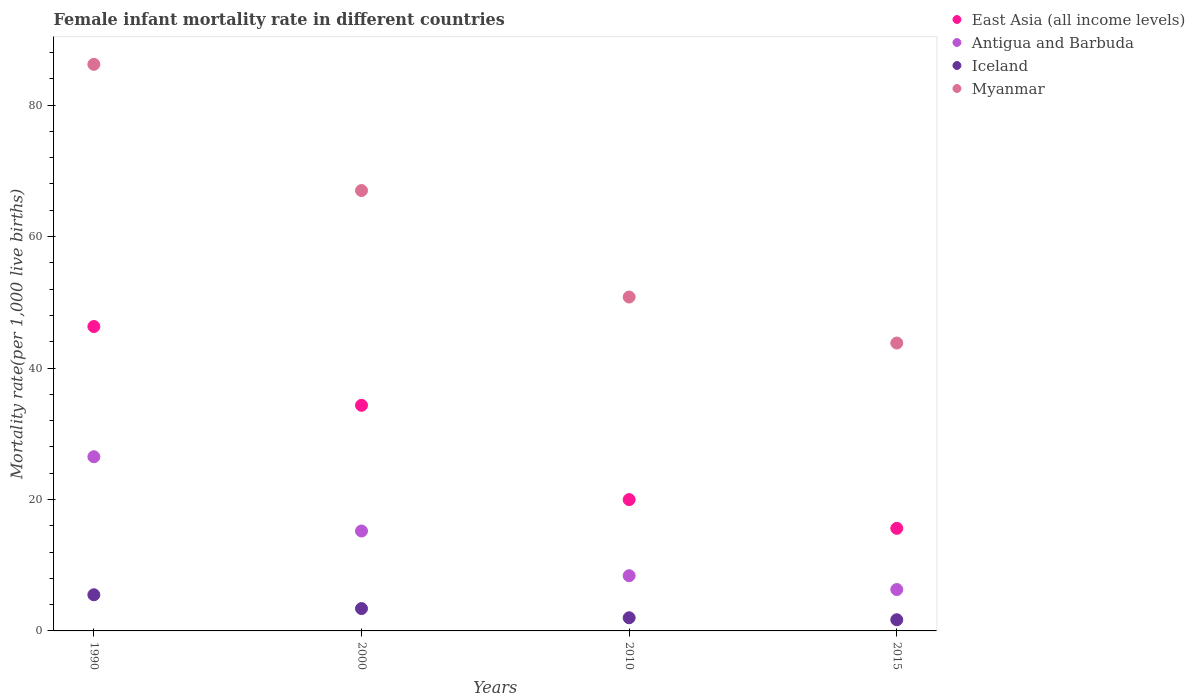How many different coloured dotlines are there?
Provide a succinct answer. 4. What is the female infant mortality rate in Myanmar in 2000?
Provide a short and direct response. 67. Across all years, what is the maximum female infant mortality rate in Iceland?
Provide a short and direct response. 5.5. In which year was the female infant mortality rate in East Asia (all income levels) maximum?
Keep it short and to the point. 1990. In which year was the female infant mortality rate in East Asia (all income levels) minimum?
Keep it short and to the point. 2015. What is the total female infant mortality rate in Antigua and Barbuda in the graph?
Your response must be concise. 56.4. What is the difference between the female infant mortality rate in Myanmar in 2015 and the female infant mortality rate in East Asia (all income levels) in 2010?
Your response must be concise. 23.82. What is the average female infant mortality rate in East Asia (all income levels) per year?
Ensure brevity in your answer.  29.06. In how many years, is the female infant mortality rate in Antigua and Barbuda greater than 52?
Offer a terse response. 0. Is the difference between the female infant mortality rate in Antigua and Barbuda in 2000 and 2015 greater than the difference between the female infant mortality rate in Iceland in 2000 and 2015?
Offer a very short reply. Yes. What is the difference between the highest and the second highest female infant mortality rate in Iceland?
Provide a short and direct response. 2.1. What is the difference between the highest and the lowest female infant mortality rate in Myanmar?
Make the answer very short. 42.4. Is the sum of the female infant mortality rate in Antigua and Barbuda in 2010 and 2015 greater than the maximum female infant mortality rate in Myanmar across all years?
Ensure brevity in your answer.  No. Is it the case that in every year, the sum of the female infant mortality rate in Myanmar and female infant mortality rate in East Asia (all income levels)  is greater than the sum of female infant mortality rate in Antigua and Barbuda and female infant mortality rate in Iceland?
Your response must be concise. Yes. Is it the case that in every year, the sum of the female infant mortality rate in Myanmar and female infant mortality rate in East Asia (all income levels)  is greater than the female infant mortality rate in Iceland?
Keep it short and to the point. Yes. Does the female infant mortality rate in Antigua and Barbuda monotonically increase over the years?
Ensure brevity in your answer.  No. Is the female infant mortality rate in Iceland strictly greater than the female infant mortality rate in Myanmar over the years?
Offer a very short reply. No. What is the difference between two consecutive major ticks on the Y-axis?
Offer a very short reply. 20. Are the values on the major ticks of Y-axis written in scientific E-notation?
Give a very brief answer. No. Where does the legend appear in the graph?
Keep it short and to the point. Top right. How many legend labels are there?
Provide a short and direct response. 4. What is the title of the graph?
Your answer should be compact. Female infant mortality rate in different countries. What is the label or title of the X-axis?
Offer a very short reply. Years. What is the label or title of the Y-axis?
Your answer should be compact. Mortality rate(per 1,0 live births). What is the Mortality rate(per 1,000 live births) in East Asia (all income levels) in 1990?
Ensure brevity in your answer.  46.31. What is the Mortality rate(per 1,000 live births) in Myanmar in 1990?
Your answer should be compact. 86.2. What is the Mortality rate(per 1,000 live births) in East Asia (all income levels) in 2000?
Make the answer very short. 34.33. What is the Mortality rate(per 1,000 live births) in East Asia (all income levels) in 2010?
Keep it short and to the point. 19.98. What is the Mortality rate(per 1,000 live births) in Iceland in 2010?
Give a very brief answer. 2. What is the Mortality rate(per 1,000 live births) in Myanmar in 2010?
Offer a very short reply. 50.8. What is the Mortality rate(per 1,000 live births) in East Asia (all income levels) in 2015?
Keep it short and to the point. 15.6. What is the Mortality rate(per 1,000 live births) in Antigua and Barbuda in 2015?
Your response must be concise. 6.3. What is the Mortality rate(per 1,000 live births) of Iceland in 2015?
Ensure brevity in your answer.  1.7. What is the Mortality rate(per 1,000 live births) of Myanmar in 2015?
Offer a terse response. 43.8. Across all years, what is the maximum Mortality rate(per 1,000 live births) in East Asia (all income levels)?
Offer a terse response. 46.31. Across all years, what is the maximum Mortality rate(per 1,000 live births) in Iceland?
Offer a very short reply. 5.5. Across all years, what is the maximum Mortality rate(per 1,000 live births) in Myanmar?
Ensure brevity in your answer.  86.2. Across all years, what is the minimum Mortality rate(per 1,000 live births) of East Asia (all income levels)?
Keep it short and to the point. 15.6. Across all years, what is the minimum Mortality rate(per 1,000 live births) of Antigua and Barbuda?
Your response must be concise. 6.3. Across all years, what is the minimum Mortality rate(per 1,000 live births) in Myanmar?
Ensure brevity in your answer.  43.8. What is the total Mortality rate(per 1,000 live births) in East Asia (all income levels) in the graph?
Give a very brief answer. 116.22. What is the total Mortality rate(per 1,000 live births) of Antigua and Barbuda in the graph?
Your response must be concise. 56.4. What is the total Mortality rate(per 1,000 live births) in Iceland in the graph?
Provide a short and direct response. 12.6. What is the total Mortality rate(per 1,000 live births) in Myanmar in the graph?
Keep it short and to the point. 247.8. What is the difference between the Mortality rate(per 1,000 live births) of East Asia (all income levels) in 1990 and that in 2000?
Offer a terse response. 11.99. What is the difference between the Mortality rate(per 1,000 live births) of Iceland in 1990 and that in 2000?
Give a very brief answer. 2.1. What is the difference between the Mortality rate(per 1,000 live births) of Myanmar in 1990 and that in 2000?
Provide a short and direct response. 19.2. What is the difference between the Mortality rate(per 1,000 live births) in East Asia (all income levels) in 1990 and that in 2010?
Keep it short and to the point. 26.33. What is the difference between the Mortality rate(per 1,000 live births) in Antigua and Barbuda in 1990 and that in 2010?
Offer a very short reply. 18.1. What is the difference between the Mortality rate(per 1,000 live births) of Iceland in 1990 and that in 2010?
Make the answer very short. 3.5. What is the difference between the Mortality rate(per 1,000 live births) in Myanmar in 1990 and that in 2010?
Give a very brief answer. 35.4. What is the difference between the Mortality rate(per 1,000 live births) in East Asia (all income levels) in 1990 and that in 2015?
Provide a short and direct response. 30.71. What is the difference between the Mortality rate(per 1,000 live births) in Antigua and Barbuda in 1990 and that in 2015?
Ensure brevity in your answer.  20.2. What is the difference between the Mortality rate(per 1,000 live births) of Myanmar in 1990 and that in 2015?
Make the answer very short. 42.4. What is the difference between the Mortality rate(per 1,000 live births) of East Asia (all income levels) in 2000 and that in 2010?
Give a very brief answer. 14.35. What is the difference between the Mortality rate(per 1,000 live births) of Antigua and Barbuda in 2000 and that in 2010?
Your answer should be compact. 6.8. What is the difference between the Mortality rate(per 1,000 live births) in East Asia (all income levels) in 2000 and that in 2015?
Provide a short and direct response. 18.72. What is the difference between the Mortality rate(per 1,000 live births) in Iceland in 2000 and that in 2015?
Provide a succinct answer. 1.7. What is the difference between the Mortality rate(per 1,000 live births) of Myanmar in 2000 and that in 2015?
Make the answer very short. 23.2. What is the difference between the Mortality rate(per 1,000 live births) of East Asia (all income levels) in 2010 and that in 2015?
Give a very brief answer. 4.37. What is the difference between the Mortality rate(per 1,000 live births) in Myanmar in 2010 and that in 2015?
Your answer should be very brief. 7. What is the difference between the Mortality rate(per 1,000 live births) in East Asia (all income levels) in 1990 and the Mortality rate(per 1,000 live births) in Antigua and Barbuda in 2000?
Make the answer very short. 31.11. What is the difference between the Mortality rate(per 1,000 live births) of East Asia (all income levels) in 1990 and the Mortality rate(per 1,000 live births) of Iceland in 2000?
Provide a succinct answer. 42.91. What is the difference between the Mortality rate(per 1,000 live births) of East Asia (all income levels) in 1990 and the Mortality rate(per 1,000 live births) of Myanmar in 2000?
Offer a very short reply. -20.69. What is the difference between the Mortality rate(per 1,000 live births) of Antigua and Barbuda in 1990 and the Mortality rate(per 1,000 live births) of Iceland in 2000?
Keep it short and to the point. 23.1. What is the difference between the Mortality rate(per 1,000 live births) of Antigua and Barbuda in 1990 and the Mortality rate(per 1,000 live births) of Myanmar in 2000?
Your answer should be very brief. -40.5. What is the difference between the Mortality rate(per 1,000 live births) in Iceland in 1990 and the Mortality rate(per 1,000 live births) in Myanmar in 2000?
Offer a very short reply. -61.5. What is the difference between the Mortality rate(per 1,000 live births) in East Asia (all income levels) in 1990 and the Mortality rate(per 1,000 live births) in Antigua and Barbuda in 2010?
Provide a succinct answer. 37.91. What is the difference between the Mortality rate(per 1,000 live births) of East Asia (all income levels) in 1990 and the Mortality rate(per 1,000 live births) of Iceland in 2010?
Make the answer very short. 44.31. What is the difference between the Mortality rate(per 1,000 live births) in East Asia (all income levels) in 1990 and the Mortality rate(per 1,000 live births) in Myanmar in 2010?
Give a very brief answer. -4.49. What is the difference between the Mortality rate(per 1,000 live births) in Antigua and Barbuda in 1990 and the Mortality rate(per 1,000 live births) in Iceland in 2010?
Keep it short and to the point. 24.5. What is the difference between the Mortality rate(per 1,000 live births) in Antigua and Barbuda in 1990 and the Mortality rate(per 1,000 live births) in Myanmar in 2010?
Provide a short and direct response. -24.3. What is the difference between the Mortality rate(per 1,000 live births) of Iceland in 1990 and the Mortality rate(per 1,000 live births) of Myanmar in 2010?
Make the answer very short. -45.3. What is the difference between the Mortality rate(per 1,000 live births) in East Asia (all income levels) in 1990 and the Mortality rate(per 1,000 live births) in Antigua and Barbuda in 2015?
Your response must be concise. 40.01. What is the difference between the Mortality rate(per 1,000 live births) of East Asia (all income levels) in 1990 and the Mortality rate(per 1,000 live births) of Iceland in 2015?
Make the answer very short. 44.61. What is the difference between the Mortality rate(per 1,000 live births) of East Asia (all income levels) in 1990 and the Mortality rate(per 1,000 live births) of Myanmar in 2015?
Provide a short and direct response. 2.51. What is the difference between the Mortality rate(per 1,000 live births) of Antigua and Barbuda in 1990 and the Mortality rate(per 1,000 live births) of Iceland in 2015?
Provide a short and direct response. 24.8. What is the difference between the Mortality rate(per 1,000 live births) of Antigua and Barbuda in 1990 and the Mortality rate(per 1,000 live births) of Myanmar in 2015?
Keep it short and to the point. -17.3. What is the difference between the Mortality rate(per 1,000 live births) in Iceland in 1990 and the Mortality rate(per 1,000 live births) in Myanmar in 2015?
Your answer should be very brief. -38.3. What is the difference between the Mortality rate(per 1,000 live births) of East Asia (all income levels) in 2000 and the Mortality rate(per 1,000 live births) of Antigua and Barbuda in 2010?
Offer a terse response. 25.93. What is the difference between the Mortality rate(per 1,000 live births) in East Asia (all income levels) in 2000 and the Mortality rate(per 1,000 live births) in Iceland in 2010?
Provide a short and direct response. 32.33. What is the difference between the Mortality rate(per 1,000 live births) in East Asia (all income levels) in 2000 and the Mortality rate(per 1,000 live births) in Myanmar in 2010?
Ensure brevity in your answer.  -16.47. What is the difference between the Mortality rate(per 1,000 live births) in Antigua and Barbuda in 2000 and the Mortality rate(per 1,000 live births) in Iceland in 2010?
Make the answer very short. 13.2. What is the difference between the Mortality rate(per 1,000 live births) of Antigua and Barbuda in 2000 and the Mortality rate(per 1,000 live births) of Myanmar in 2010?
Your answer should be compact. -35.6. What is the difference between the Mortality rate(per 1,000 live births) in Iceland in 2000 and the Mortality rate(per 1,000 live births) in Myanmar in 2010?
Your response must be concise. -47.4. What is the difference between the Mortality rate(per 1,000 live births) of East Asia (all income levels) in 2000 and the Mortality rate(per 1,000 live births) of Antigua and Barbuda in 2015?
Offer a terse response. 28.03. What is the difference between the Mortality rate(per 1,000 live births) in East Asia (all income levels) in 2000 and the Mortality rate(per 1,000 live births) in Iceland in 2015?
Your answer should be very brief. 32.63. What is the difference between the Mortality rate(per 1,000 live births) in East Asia (all income levels) in 2000 and the Mortality rate(per 1,000 live births) in Myanmar in 2015?
Give a very brief answer. -9.47. What is the difference between the Mortality rate(per 1,000 live births) of Antigua and Barbuda in 2000 and the Mortality rate(per 1,000 live births) of Iceland in 2015?
Keep it short and to the point. 13.5. What is the difference between the Mortality rate(per 1,000 live births) in Antigua and Barbuda in 2000 and the Mortality rate(per 1,000 live births) in Myanmar in 2015?
Your response must be concise. -28.6. What is the difference between the Mortality rate(per 1,000 live births) of Iceland in 2000 and the Mortality rate(per 1,000 live births) of Myanmar in 2015?
Provide a succinct answer. -40.4. What is the difference between the Mortality rate(per 1,000 live births) in East Asia (all income levels) in 2010 and the Mortality rate(per 1,000 live births) in Antigua and Barbuda in 2015?
Provide a succinct answer. 13.68. What is the difference between the Mortality rate(per 1,000 live births) in East Asia (all income levels) in 2010 and the Mortality rate(per 1,000 live births) in Iceland in 2015?
Your answer should be very brief. 18.28. What is the difference between the Mortality rate(per 1,000 live births) in East Asia (all income levels) in 2010 and the Mortality rate(per 1,000 live births) in Myanmar in 2015?
Your answer should be very brief. -23.82. What is the difference between the Mortality rate(per 1,000 live births) of Antigua and Barbuda in 2010 and the Mortality rate(per 1,000 live births) of Myanmar in 2015?
Your answer should be compact. -35.4. What is the difference between the Mortality rate(per 1,000 live births) of Iceland in 2010 and the Mortality rate(per 1,000 live births) of Myanmar in 2015?
Provide a succinct answer. -41.8. What is the average Mortality rate(per 1,000 live births) in East Asia (all income levels) per year?
Make the answer very short. 29.06. What is the average Mortality rate(per 1,000 live births) of Iceland per year?
Give a very brief answer. 3.15. What is the average Mortality rate(per 1,000 live births) of Myanmar per year?
Give a very brief answer. 61.95. In the year 1990, what is the difference between the Mortality rate(per 1,000 live births) in East Asia (all income levels) and Mortality rate(per 1,000 live births) in Antigua and Barbuda?
Provide a short and direct response. 19.81. In the year 1990, what is the difference between the Mortality rate(per 1,000 live births) in East Asia (all income levels) and Mortality rate(per 1,000 live births) in Iceland?
Your answer should be compact. 40.81. In the year 1990, what is the difference between the Mortality rate(per 1,000 live births) of East Asia (all income levels) and Mortality rate(per 1,000 live births) of Myanmar?
Provide a succinct answer. -39.89. In the year 1990, what is the difference between the Mortality rate(per 1,000 live births) in Antigua and Barbuda and Mortality rate(per 1,000 live births) in Myanmar?
Provide a succinct answer. -59.7. In the year 1990, what is the difference between the Mortality rate(per 1,000 live births) of Iceland and Mortality rate(per 1,000 live births) of Myanmar?
Keep it short and to the point. -80.7. In the year 2000, what is the difference between the Mortality rate(per 1,000 live births) of East Asia (all income levels) and Mortality rate(per 1,000 live births) of Antigua and Barbuda?
Offer a very short reply. 19.13. In the year 2000, what is the difference between the Mortality rate(per 1,000 live births) of East Asia (all income levels) and Mortality rate(per 1,000 live births) of Iceland?
Provide a short and direct response. 30.93. In the year 2000, what is the difference between the Mortality rate(per 1,000 live births) of East Asia (all income levels) and Mortality rate(per 1,000 live births) of Myanmar?
Your answer should be compact. -32.67. In the year 2000, what is the difference between the Mortality rate(per 1,000 live births) in Antigua and Barbuda and Mortality rate(per 1,000 live births) in Myanmar?
Give a very brief answer. -51.8. In the year 2000, what is the difference between the Mortality rate(per 1,000 live births) of Iceland and Mortality rate(per 1,000 live births) of Myanmar?
Provide a short and direct response. -63.6. In the year 2010, what is the difference between the Mortality rate(per 1,000 live births) in East Asia (all income levels) and Mortality rate(per 1,000 live births) in Antigua and Barbuda?
Provide a succinct answer. 11.58. In the year 2010, what is the difference between the Mortality rate(per 1,000 live births) of East Asia (all income levels) and Mortality rate(per 1,000 live births) of Iceland?
Your answer should be very brief. 17.98. In the year 2010, what is the difference between the Mortality rate(per 1,000 live births) in East Asia (all income levels) and Mortality rate(per 1,000 live births) in Myanmar?
Provide a succinct answer. -30.82. In the year 2010, what is the difference between the Mortality rate(per 1,000 live births) in Antigua and Barbuda and Mortality rate(per 1,000 live births) in Iceland?
Offer a very short reply. 6.4. In the year 2010, what is the difference between the Mortality rate(per 1,000 live births) in Antigua and Barbuda and Mortality rate(per 1,000 live births) in Myanmar?
Your answer should be very brief. -42.4. In the year 2010, what is the difference between the Mortality rate(per 1,000 live births) of Iceland and Mortality rate(per 1,000 live births) of Myanmar?
Keep it short and to the point. -48.8. In the year 2015, what is the difference between the Mortality rate(per 1,000 live births) in East Asia (all income levels) and Mortality rate(per 1,000 live births) in Antigua and Barbuda?
Ensure brevity in your answer.  9.3. In the year 2015, what is the difference between the Mortality rate(per 1,000 live births) of East Asia (all income levels) and Mortality rate(per 1,000 live births) of Iceland?
Your answer should be compact. 13.9. In the year 2015, what is the difference between the Mortality rate(per 1,000 live births) of East Asia (all income levels) and Mortality rate(per 1,000 live births) of Myanmar?
Provide a short and direct response. -28.2. In the year 2015, what is the difference between the Mortality rate(per 1,000 live births) in Antigua and Barbuda and Mortality rate(per 1,000 live births) in Myanmar?
Offer a very short reply. -37.5. In the year 2015, what is the difference between the Mortality rate(per 1,000 live births) in Iceland and Mortality rate(per 1,000 live births) in Myanmar?
Your response must be concise. -42.1. What is the ratio of the Mortality rate(per 1,000 live births) in East Asia (all income levels) in 1990 to that in 2000?
Offer a very short reply. 1.35. What is the ratio of the Mortality rate(per 1,000 live births) of Antigua and Barbuda in 1990 to that in 2000?
Offer a terse response. 1.74. What is the ratio of the Mortality rate(per 1,000 live births) of Iceland in 1990 to that in 2000?
Offer a very short reply. 1.62. What is the ratio of the Mortality rate(per 1,000 live births) of Myanmar in 1990 to that in 2000?
Provide a short and direct response. 1.29. What is the ratio of the Mortality rate(per 1,000 live births) of East Asia (all income levels) in 1990 to that in 2010?
Your answer should be very brief. 2.32. What is the ratio of the Mortality rate(per 1,000 live births) in Antigua and Barbuda in 1990 to that in 2010?
Give a very brief answer. 3.15. What is the ratio of the Mortality rate(per 1,000 live births) of Iceland in 1990 to that in 2010?
Offer a very short reply. 2.75. What is the ratio of the Mortality rate(per 1,000 live births) of Myanmar in 1990 to that in 2010?
Your response must be concise. 1.7. What is the ratio of the Mortality rate(per 1,000 live births) of East Asia (all income levels) in 1990 to that in 2015?
Your answer should be compact. 2.97. What is the ratio of the Mortality rate(per 1,000 live births) in Antigua and Barbuda in 1990 to that in 2015?
Make the answer very short. 4.21. What is the ratio of the Mortality rate(per 1,000 live births) of Iceland in 1990 to that in 2015?
Make the answer very short. 3.24. What is the ratio of the Mortality rate(per 1,000 live births) in Myanmar in 1990 to that in 2015?
Ensure brevity in your answer.  1.97. What is the ratio of the Mortality rate(per 1,000 live births) in East Asia (all income levels) in 2000 to that in 2010?
Provide a short and direct response. 1.72. What is the ratio of the Mortality rate(per 1,000 live births) in Antigua and Barbuda in 2000 to that in 2010?
Provide a short and direct response. 1.81. What is the ratio of the Mortality rate(per 1,000 live births) of Iceland in 2000 to that in 2010?
Your answer should be compact. 1.7. What is the ratio of the Mortality rate(per 1,000 live births) of Myanmar in 2000 to that in 2010?
Your answer should be compact. 1.32. What is the ratio of the Mortality rate(per 1,000 live births) in East Asia (all income levels) in 2000 to that in 2015?
Offer a very short reply. 2.2. What is the ratio of the Mortality rate(per 1,000 live births) in Antigua and Barbuda in 2000 to that in 2015?
Provide a succinct answer. 2.41. What is the ratio of the Mortality rate(per 1,000 live births) of Iceland in 2000 to that in 2015?
Your answer should be very brief. 2. What is the ratio of the Mortality rate(per 1,000 live births) of Myanmar in 2000 to that in 2015?
Provide a short and direct response. 1.53. What is the ratio of the Mortality rate(per 1,000 live births) in East Asia (all income levels) in 2010 to that in 2015?
Make the answer very short. 1.28. What is the ratio of the Mortality rate(per 1,000 live births) of Antigua and Barbuda in 2010 to that in 2015?
Offer a very short reply. 1.33. What is the ratio of the Mortality rate(per 1,000 live births) of Iceland in 2010 to that in 2015?
Provide a succinct answer. 1.18. What is the ratio of the Mortality rate(per 1,000 live births) in Myanmar in 2010 to that in 2015?
Your answer should be very brief. 1.16. What is the difference between the highest and the second highest Mortality rate(per 1,000 live births) of East Asia (all income levels)?
Ensure brevity in your answer.  11.99. What is the difference between the highest and the second highest Mortality rate(per 1,000 live births) of Myanmar?
Offer a very short reply. 19.2. What is the difference between the highest and the lowest Mortality rate(per 1,000 live births) in East Asia (all income levels)?
Your answer should be compact. 30.71. What is the difference between the highest and the lowest Mortality rate(per 1,000 live births) in Antigua and Barbuda?
Make the answer very short. 20.2. What is the difference between the highest and the lowest Mortality rate(per 1,000 live births) of Iceland?
Your answer should be compact. 3.8. What is the difference between the highest and the lowest Mortality rate(per 1,000 live births) of Myanmar?
Your answer should be compact. 42.4. 